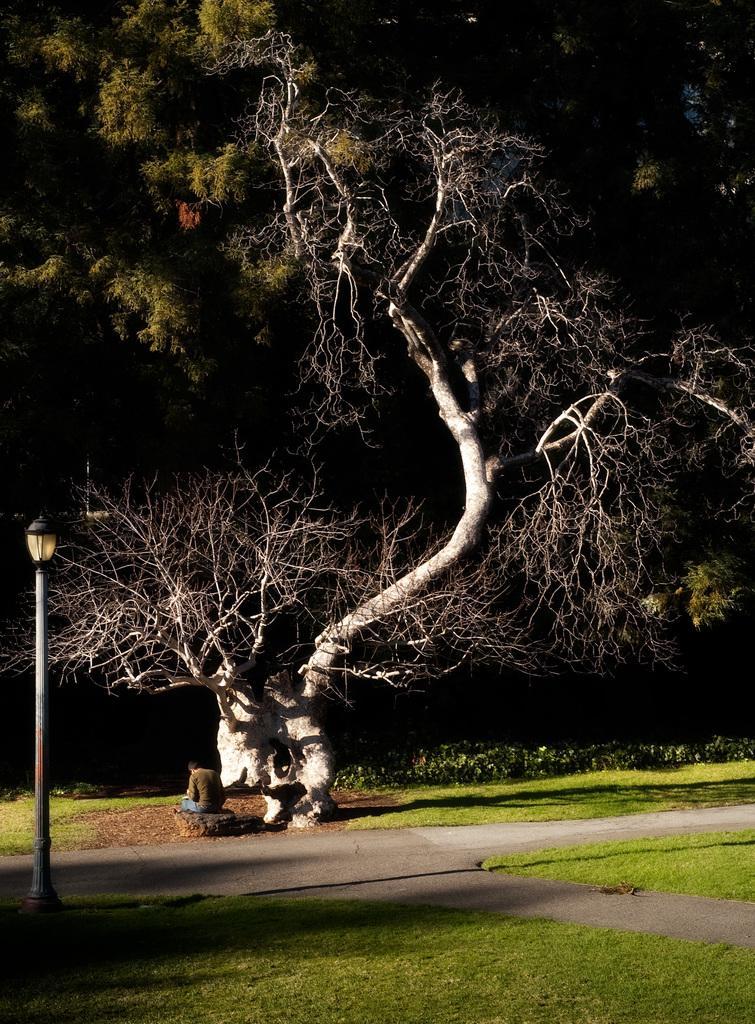Can you describe this image briefly? In this picture we can see a person sitting, pole with a lamp, grass, path and a tree. 